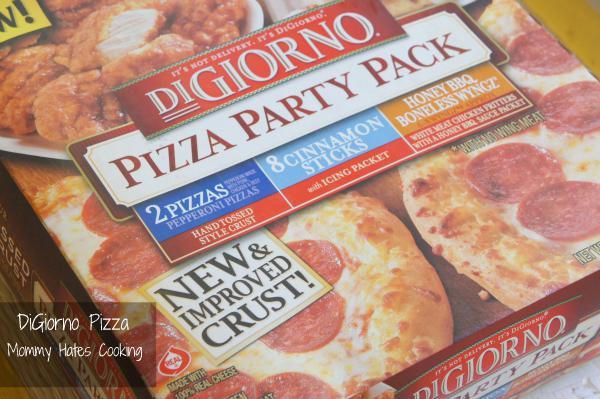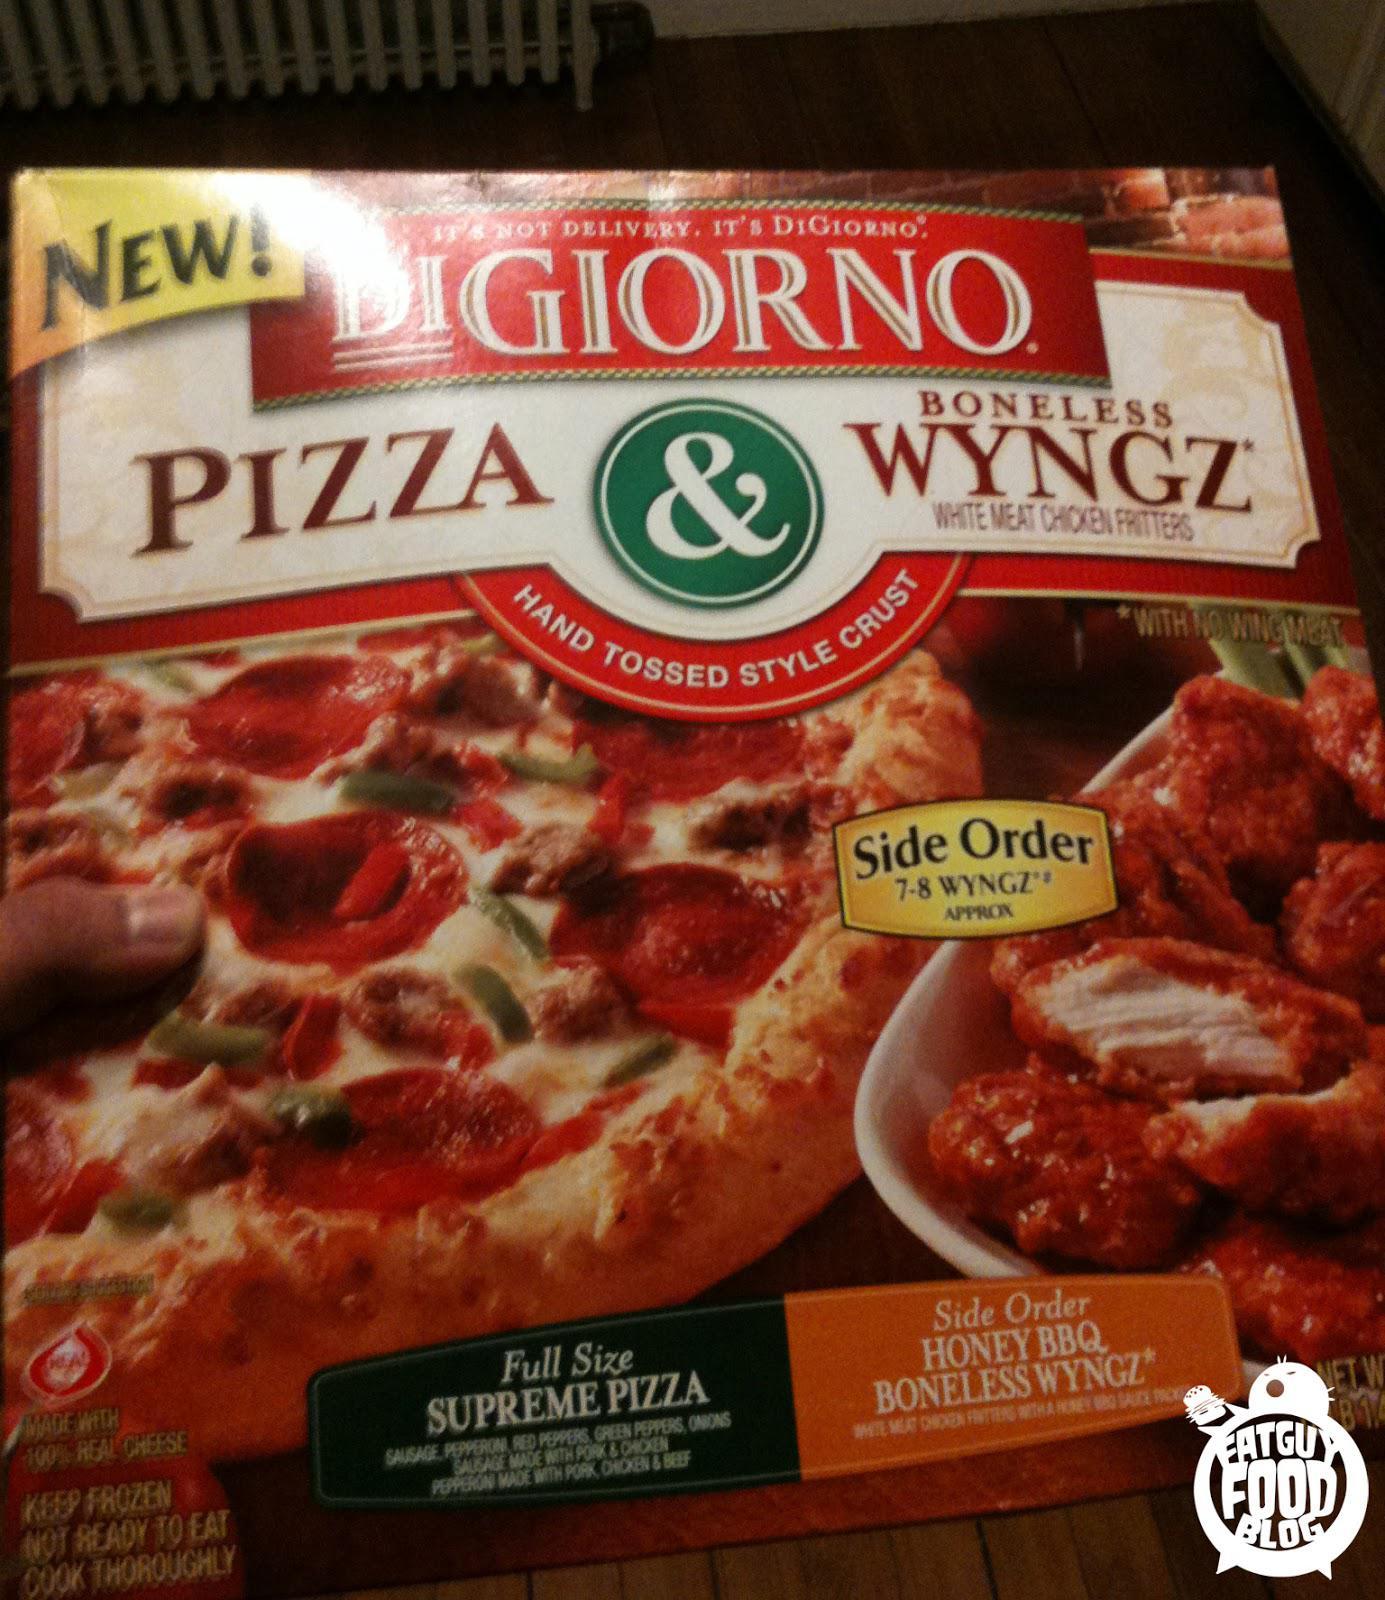The first image is the image on the left, the second image is the image on the right. Given the left and right images, does the statement "An image shows a pizza box that depicts pizza on the left and coated chicken pieces on the right." hold true? Answer yes or no. Yes. 